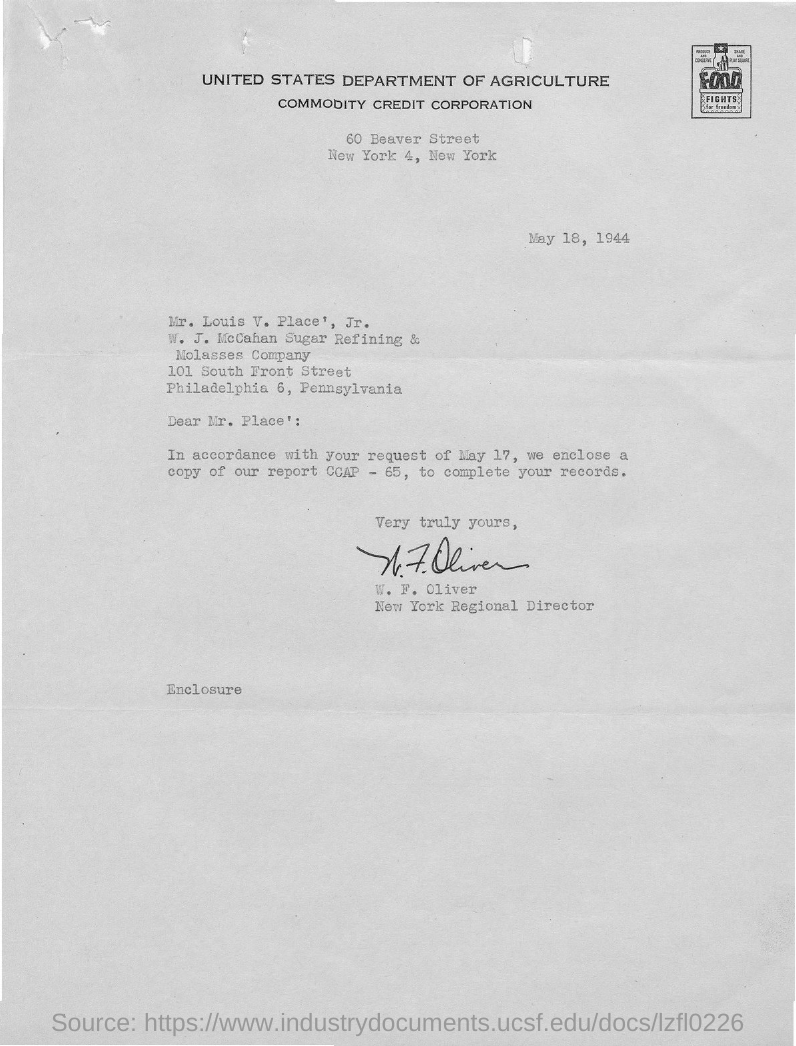Which state is the commodity credit corporation in?
Give a very brief answer. New York. To whom is the letter addressed ?
Give a very brief answer. Mr. Louis V. Place. Whom is the letter from?
Your response must be concise. W. F. Oliver. What is the designation of W. F. Oliver?
Keep it short and to the point. New York Regional Director. Which company is Mr. Louis V. place from?
Keep it short and to the point. W. J. McCahan Sugar Refining & Molasses Company. What copy is enclosed?
Your response must be concise. Report ccap - 65. 